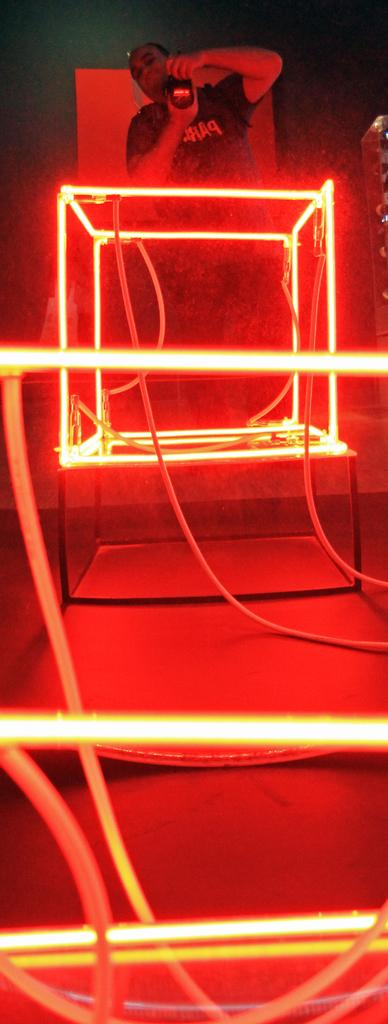What is the main subject of the image? There is a person in the image. What is the person holding in his hand? The person is holding a camera in his hand. Where is the person standing in relation to the box? The person is standing behind the box. What can be seen on the box? The box has lights on it. What type of sofa is visible in the image? There is no sofa present in the image. 